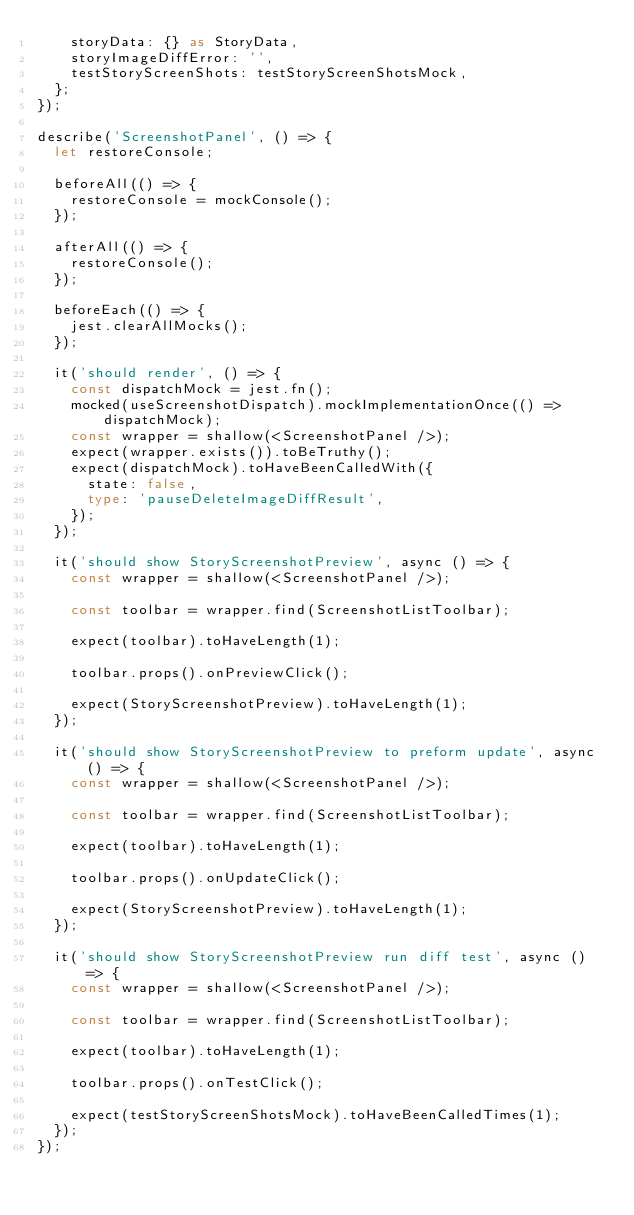Convert code to text. <code><loc_0><loc_0><loc_500><loc_500><_TypeScript_>    storyData: {} as StoryData,
    storyImageDiffError: '',
    testStoryScreenShots: testStoryScreenShotsMock,
  };
});

describe('ScreenshotPanel', () => {
  let restoreConsole;

  beforeAll(() => {
    restoreConsole = mockConsole();
  });

  afterAll(() => {
    restoreConsole();
  });

  beforeEach(() => {
    jest.clearAllMocks();
  });

  it('should render', () => {
    const dispatchMock = jest.fn();
    mocked(useScreenshotDispatch).mockImplementationOnce(() => dispatchMock);
    const wrapper = shallow(<ScreenshotPanel />);
    expect(wrapper.exists()).toBeTruthy();
    expect(dispatchMock).toHaveBeenCalledWith({
      state: false,
      type: 'pauseDeleteImageDiffResult',
    });
  });

  it('should show StoryScreenshotPreview', async () => {
    const wrapper = shallow(<ScreenshotPanel />);

    const toolbar = wrapper.find(ScreenshotListToolbar);

    expect(toolbar).toHaveLength(1);

    toolbar.props().onPreviewClick();

    expect(StoryScreenshotPreview).toHaveLength(1);
  });

  it('should show StoryScreenshotPreview to preform update', async () => {
    const wrapper = shallow(<ScreenshotPanel />);

    const toolbar = wrapper.find(ScreenshotListToolbar);

    expect(toolbar).toHaveLength(1);

    toolbar.props().onUpdateClick();

    expect(StoryScreenshotPreview).toHaveLength(1);
  });

  it('should show StoryScreenshotPreview run diff test', async () => {
    const wrapper = shallow(<ScreenshotPanel />);

    const toolbar = wrapper.find(ScreenshotListToolbar);

    expect(toolbar).toHaveLength(1);

    toolbar.props().onTestClick();

    expect(testStoryScreenShotsMock).toHaveBeenCalledTimes(1);
  });
});
</code> 